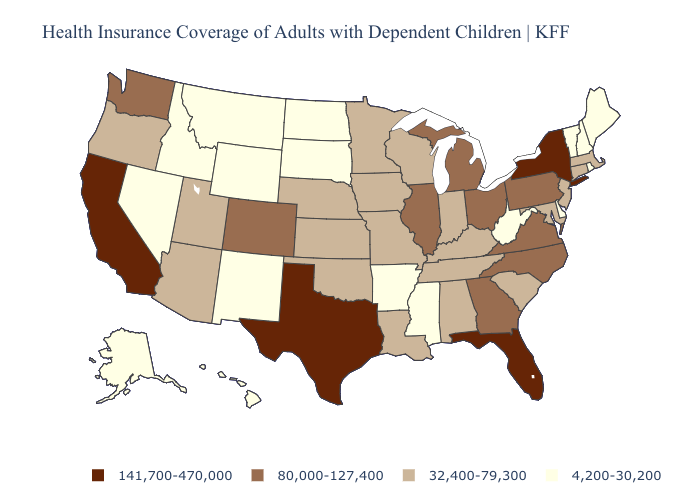Among the states that border Oklahoma , which have the lowest value?
Quick response, please. Arkansas, New Mexico. Which states hav the highest value in the MidWest?
Give a very brief answer. Illinois, Michigan, Ohio. What is the lowest value in states that border Kansas?
Answer briefly. 32,400-79,300. Name the states that have a value in the range 141,700-470,000?
Short answer required. California, Florida, New York, Texas. What is the value of Idaho?
Concise answer only. 4,200-30,200. Which states hav the highest value in the Northeast?
Keep it brief. New York. What is the value of North Dakota?
Quick response, please. 4,200-30,200. Does the map have missing data?
Concise answer only. No. Name the states that have a value in the range 32,400-79,300?
Short answer required. Alabama, Arizona, Connecticut, Indiana, Iowa, Kansas, Kentucky, Louisiana, Maryland, Massachusetts, Minnesota, Missouri, Nebraska, New Jersey, Oklahoma, Oregon, South Carolina, Tennessee, Utah, Wisconsin. Which states hav the highest value in the West?
Write a very short answer. California. Among the states that border Colorado , which have the highest value?
Answer briefly. Arizona, Kansas, Nebraska, Oklahoma, Utah. Which states have the lowest value in the USA?
Quick response, please. Alaska, Arkansas, Delaware, Hawaii, Idaho, Maine, Mississippi, Montana, Nevada, New Hampshire, New Mexico, North Dakota, Rhode Island, South Dakota, Vermont, West Virginia, Wyoming. What is the value of Virginia?
Give a very brief answer. 80,000-127,400. How many symbols are there in the legend?
Write a very short answer. 4. Does Minnesota have a higher value than Massachusetts?
Answer briefly. No. 